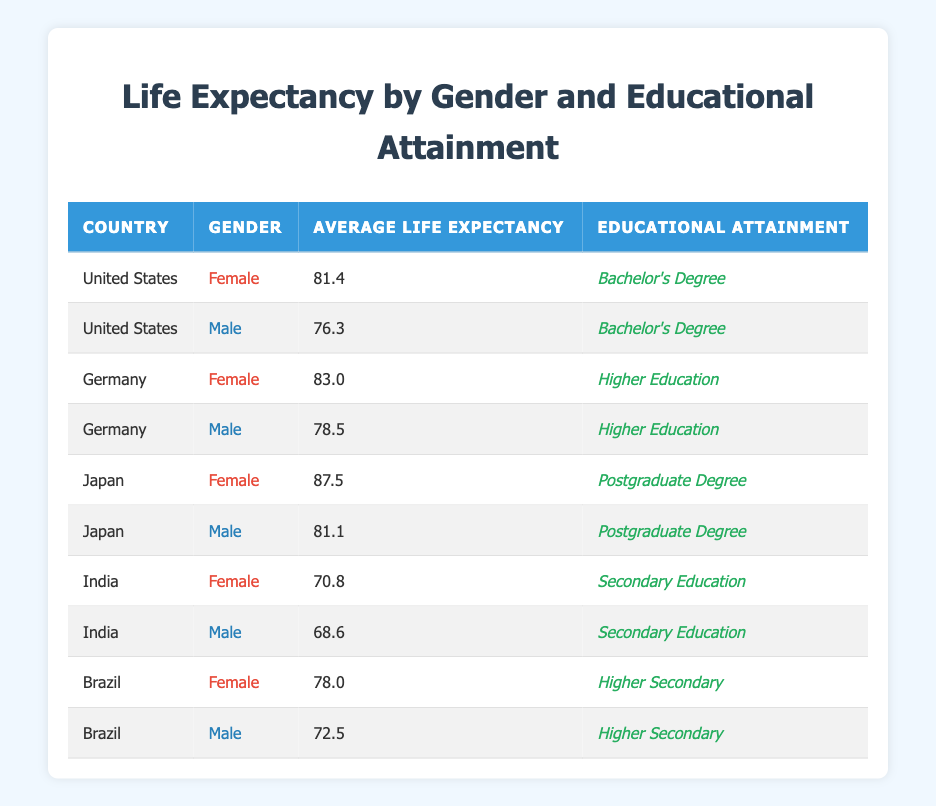What is the average life expectancy for females in the United States? From the table, in the United States, the life expectancy for females is 81.4.
Answer: 81.4 What is the average life expectancy of males in Germany? In Germany, the average life expectancy for males is listed as 78.5.
Answer: 78.5 Which country has the highest average life expectancy for females? Japan has the highest average life expectancy for females at 87.5, as shown in the table.
Answer: Japan What is the difference in life expectancy between males and females in India? In India, females have an average life expectancy of 70.8 and males 68.6. The difference is 70.8 - 68.6 = 2.2.
Answer: 2.2 Do females in Brazil have a higher life expectancy than males in Germany? In Brazil, females have a life expectancy of 78.0, while in Germany, males have a life expectancy of 78.5. Since 78.0 is less than 78.5, the answer is no.
Answer: No What is the average life expectancy of males with a postgraduate degree across the three countries in the table? The average life expectancy for males with a postgraduate degree is: (81.1 from Japan) = 81.1, since Japan is the only country reported with that education level for males.
Answer: 81.1 Is the life expectancy for females with a higher education level greater than for males with a higher secondary education in Brazil? In Brazil, females have a life expectancy of 78.0 (higher secondary), and males have a life expectancy of 72.5 (higher secondary). Since 78.0 is greater than 72.5, the answer is yes.
Answer: Yes What is the average life expectancy for all individuals in Germany? The average life expectancy in Germany can be calculated by taking the life expectancy of females (83.0) and males (78.5). Thus, the average is (83.0 + 78.5) / 2 = 80.75.
Answer: 80.75 Which educational attainment level has the highest life expectancy for females, and what is that life expectancy? According to the table, females with a postgraduate degree (Japan) have the highest life expectancy of 87.5.
Answer: Postgraduate Degree, 87.5 What is the average life expectancy for males with a secondary education across the countries listed? The average for males with secondary education is calculated as follows: (68.6 from India + 72.5 from Brazil) / 2 = 70.55.
Answer: 70.55 